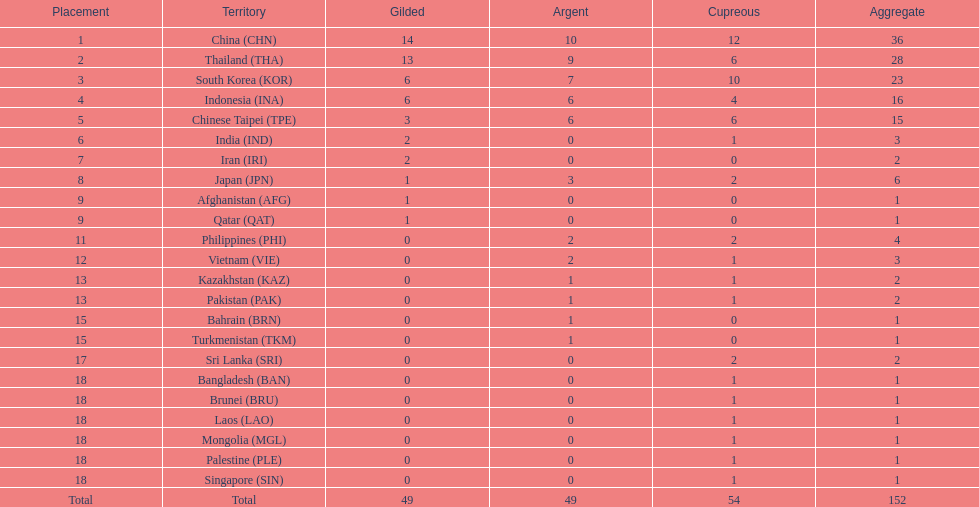Which countries won the same number of gold medals as japan? Afghanistan (AFG), Qatar (QAT). 